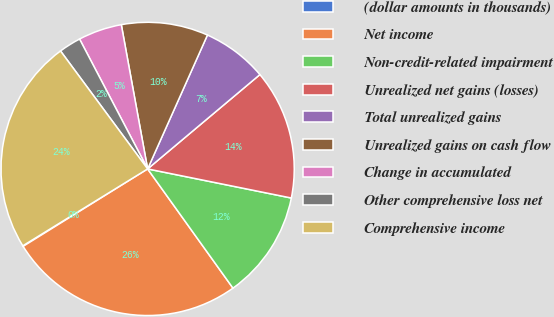Convert chart. <chart><loc_0><loc_0><loc_500><loc_500><pie_chart><fcel>(dollar amounts in thousands)<fcel>Net income<fcel>Non-credit-related impairment<fcel>Unrealized net gains (losses)<fcel>Total unrealized gains<fcel>Unrealized gains on cash flow<fcel>Change in accumulated<fcel>Other comprehensive loss net<fcel>Comprehensive income<nl><fcel>0.07%<fcel>26.03%<fcel>11.93%<fcel>14.3%<fcel>7.19%<fcel>9.56%<fcel>4.81%<fcel>2.44%<fcel>23.66%<nl></chart> 